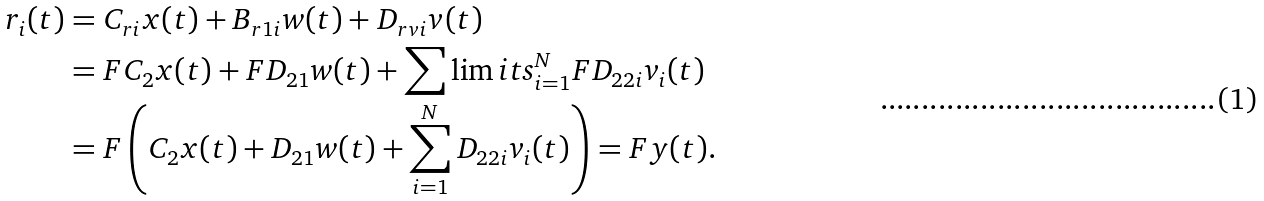Convert formula to latex. <formula><loc_0><loc_0><loc_500><loc_500>r _ { i } ( t ) & = C _ { r i } x ( t ) + B _ { r 1 i } w ( t ) + D _ { r v i } v ( t ) \\ & = F C _ { 2 } x ( t ) + F D _ { 2 1 } w ( t ) + \sum \lim i t s _ { i = 1 } ^ { N } F D _ { 2 2 i } v _ { i } ( t ) \\ & = F \left ( C _ { 2 } x ( t ) + D _ { 2 1 } w ( t ) + \sum _ { i = 1 } ^ { N } D _ { 2 2 i } v _ { i } ( t ) \right ) = F y ( t ) .</formula> 